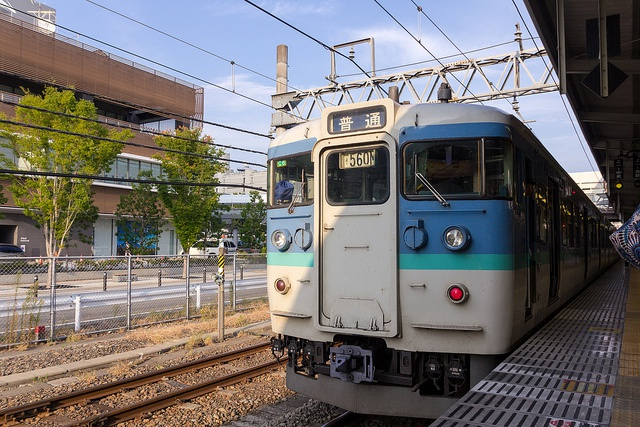Describe the objects in this image and their specific colors. I can see train in lavender, black, darkgray, gray, and beige tones, car in lavender, gray, lightgray, black, and darkgray tones, and car in lavender, black, gray, and navy tones in this image. 